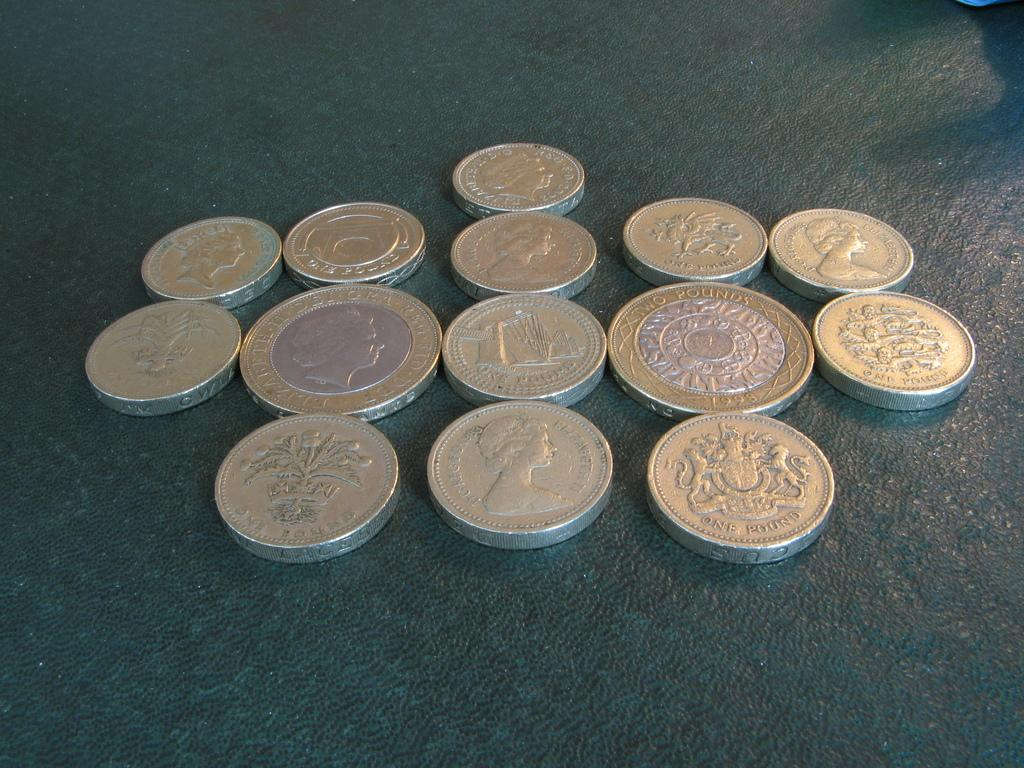<image>
Present a compact description of the photo's key features. Several British Pounds are laying on a table. 